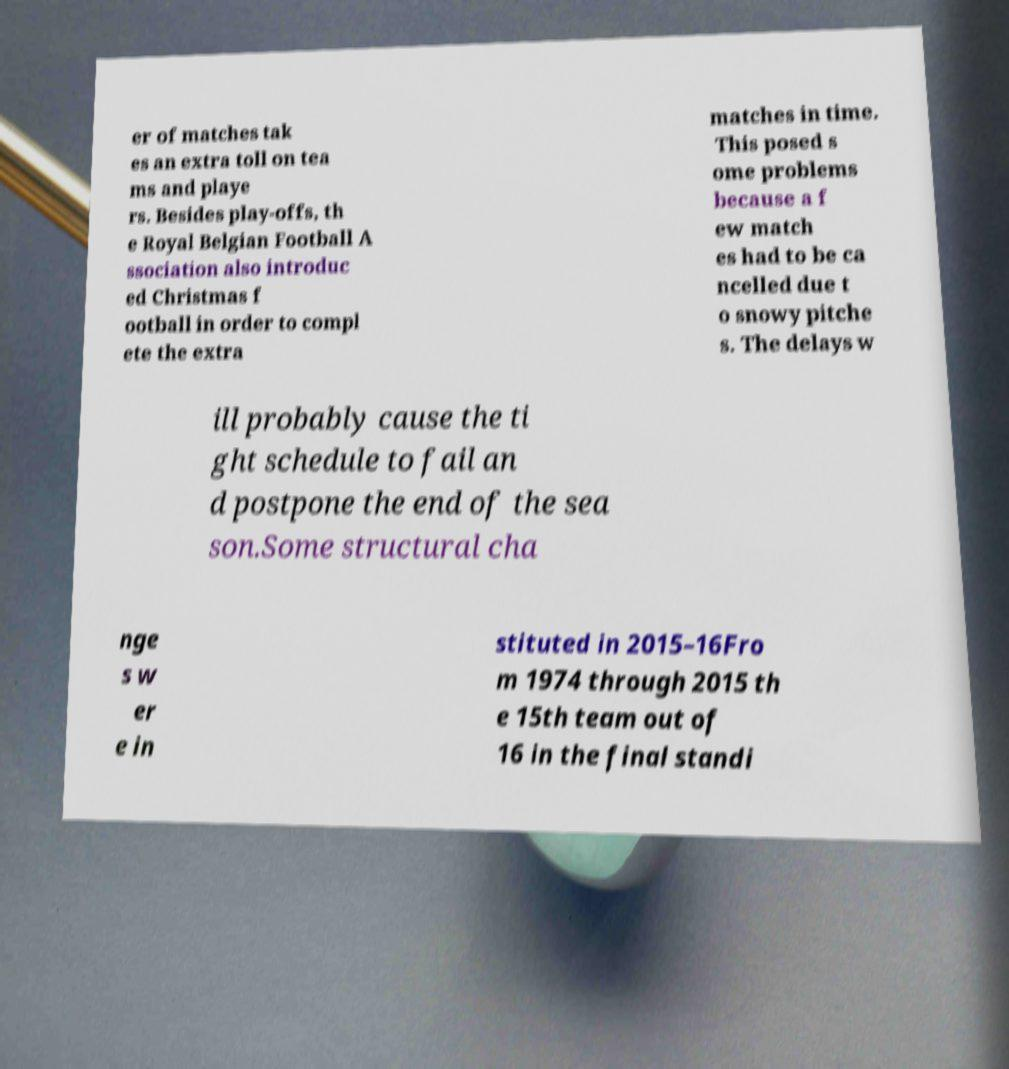Please identify and transcribe the text found in this image. er of matches tak es an extra toll on tea ms and playe rs. Besides play-offs, th e Royal Belgian Football A ssociation also introduc ed Christmas f ootball in order to compl ete the extra matches in time. This posed s ome problems because a f ew match es had to be ca ncelled due t o snowy pitche s. The delays w ill probably cause the ti ght schedule to fail an d postpone the end of the sea son.Some structural cha nge s w er e in stituted in 2015–16Fro m 1974 through 2015 th e 15th team out of 16 in the final standi 